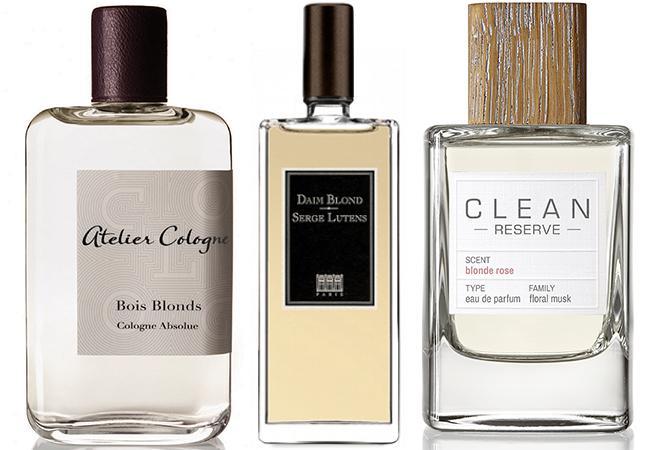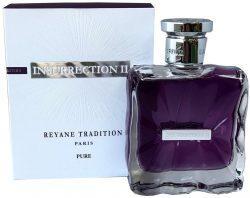The first image is the image on the left, the second image is the image on the right. For the images displayed, is the sentence "One image shows a container of perfume and the box it is sold in, while a second image shows two or more bottles of cologne arranged side by side." factually correct? Answer yes or no. Yes. The first image is the image on the left, the second image is the image on the right. Assess this claim about the two images: "At least one image contains a richly colored glass bottle with a sculpted shape.". Correct or not? Answer yes or no. Yes. 